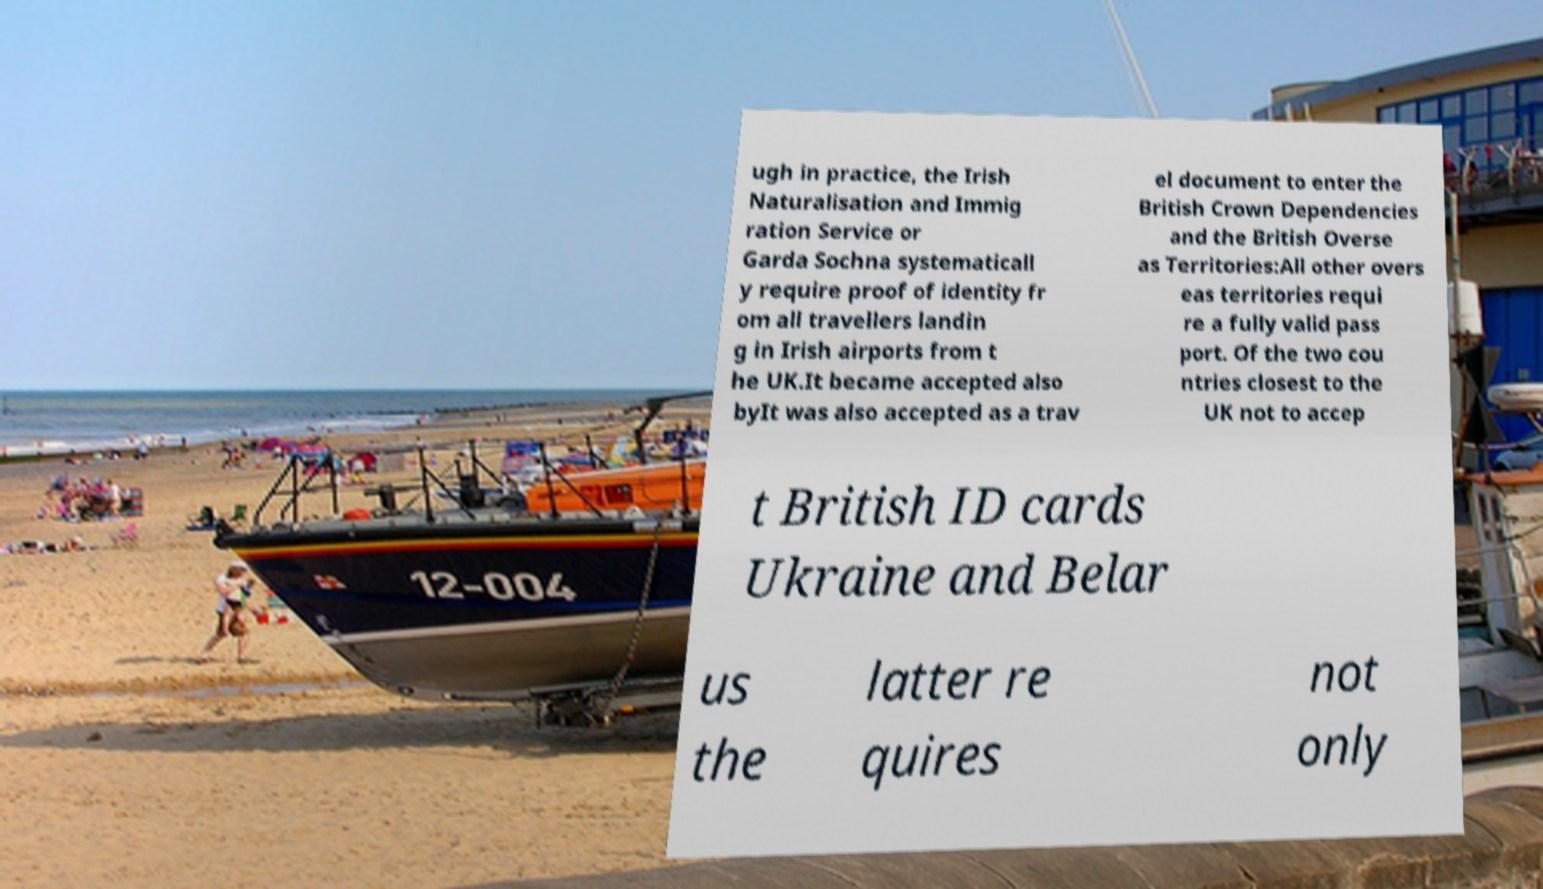Please read and relay the text visible in this image. What does it say? ugh in practice, the Irish Naturalisation and Immig ration Service or Garda Sochna systematicall y require proof of identity fr om all travellers landin g in Irish airports from t he UK.It became accepted also byIt was also accepted as a trav el document to enter the British Crown Dependencies and the British Overse as Territories:All other overs eas territories requi re a fully valid pass port. Of the two cou ntries closest to the UK not to accep t British ID cards Ukraine and Belar us the latter re quires not only 